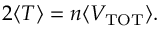Convert formula to latex. <formula><loc_0><loc_0><loc_500><loc_500>2 \langle T \rangle = n \langle V _ { T O T } \rangle .</formula> 